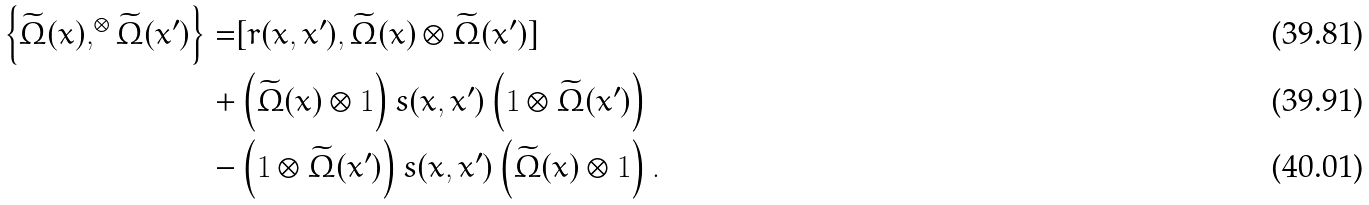Convert formula to latex. <formula><loc_0><loc_0><loc_500><loc_500>\left \{ \widetilde { \Omega } ( x ) , ^ { \otimes } \widetilde { \Omega } ( x ^ { \prime } ) \right \} = & [ r ( x , x ^ { \prime } ) , \widetilde { \Omega } ( x ) \otimes \widetilde { \Omega } ( x ^ { \prime } ) ] \\ + & \left ( \widetilde { \Omega } ( x ) \otimes { 1 } \right ) s ( x , x ^ { \prime } ) \left ( { 1 } \otimes \widetilde { \Omega } ( x ^ { \prime } ) \right ) \\ - & \left ( { 1 } \otimes \widetilde { \Omega } ( x ^ { \prime } ) \right ) s ( x , x ^ { \prime } ) \left ( \widetilde { \Omega } ( x ) \otimes { 1 } \right ) .</formula> 